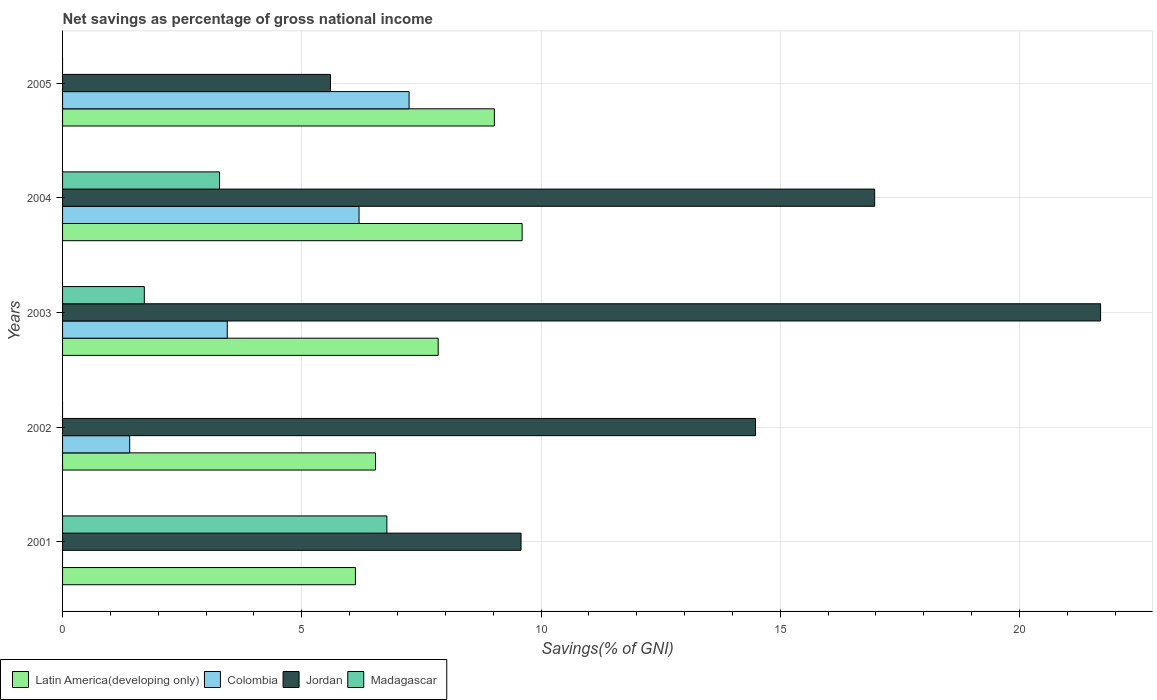How many different coloured bars are there?
Ensure brevity in your answer.  4. How many groups of bars are there?
Offer a terse response. 5. What is the total savings in Colombia in 2004?
Provide a succinct answer. 6.2. Across all years, what is the maximum total savings in Colombia?
Keep it short and to the point. 7.24. Across all years, what is the minimum total savings in Madagascar?
Make the answer very short. 0. What is the total total savings in Colombia in the graph?
Your response must be concise. 18.28. What is the difference between the total savings in Colombia in 2002 and that in 2005?
Your answer should be compact. -5.84. What is the difference between the total savings in Madagascar in 2005 and the total savings in Colombia in 2002?
Your answer should be compact. -1.4. What is the average total savings in Madagascar per year?
Provide a succinct answer. 2.35. In the year 2001, what is the difference between the total savings in Jordan and total savings in Latin America(developing only)?
Your response must be concise. 3.46. What is the ratio of the total savings in Jordan in 2002 to that in 2003?
Your response must be concise. 0.67. Is the total savings in Colombia in 2003 less than that in 2005?
Offer a terse response. Yes. Is the difference between the total savings in Jordan in 2002 and 2003 greater than the difference between the total savings in Latin America(developing only) in 2002 and 2003?
Provide a short and direct response. No. What is the difference between the highest and the second highest total savings in Madagascar?
Your response must be concise. 3.5. What is the difference between the highest and the lowest total savings in Jordan?
Ensure brevity in your answer.  16.1. Is the sum of the total savings in Jordan in 2004 and 2005 greater than the maximum total savings in Latin America(developing only) across all years?
Ensure brevity in your answer.  Yes. How many bars are there?
Your response must be concise. 17. How many legend labels are there?
Offer a terse response. 4. How are the legend labels stacked?
Your answer should be very brief. Horizontal. What is the title of the graph?
Your response must be concise. Net savings as percentage of gross national income. What is the label or title of the X-axis?
Offer a terse response. Savings(% of GNI). What is the label or title of the Y-axis?
Ensure brevity in your answer.  Years. What is the Savings(% of GNI) of Latin America(developing only) in 2001?
Offer a terse response. 6.12. What is the Savings(% of GNI) of Jordan in 2001?
Provide a succinct answer. 9.58. What is the Savings(% of GNI) in Madagascar in 2001?
Ensure brevity in your answer.  6.78. What is the Savings(% of GNI) in Latin America(developing only) in 2002?
Offer a very short reply. 6.54. What is the Savings(% of GNI) of Colombia in 2002?
Your answer should be compact. 1.4. What is the Savings(% of GNI) in Jordan in 2002?
Your response must be concise. 14.48. What is the Savings(% of GNI) of Latin America(developing only) in 2003?
Make the answer very short. 7.85. What is the Savings(% of GNI) in Colombia in 2003?
Make the answer very short. 3.44. What is the Savings(% of GNI) in Jordan in 2003?
Offer a very short reply. 21.69. What is the Savings(% of GNI) of Madagascar in 2003?
Your answer should be very brief. 1.71. What is the Savings(% of GNI) in Latin America(developing only) in 2004?
Offer a terse response. 9.6. What is the Savings(% of GNI) of Colombia in 2004?
Provide a succinct answer. 6.2. What is the Savings(% of GNI) in Jordan in 2004?
Make the answer very short. 16.97. What is the Savings(% of GNI) in Madagascar in 2004?
Ensure brevity in your answer.  3.28. What is the Savings(% of GNI) in Latin America(developing only) in 2005?
Provide a succinct answer. 9.02. What is the Savings(% of GNI) in Colombia in 2005?
Your answer should be compact. 7.24. What is the Savings(% of GNI) of Jordan in 2005?
Keep it short and to the point. 5.6. What is the Savings(% of GNI) in Madagascar in 2005?
Your response must be concise. 0. Across all years, what is the maximum Savings(% of GNI) of Latin America(developing only)?
Make the answer very short. 9.6. Across all years, what is the maximum Savings(% of GNI) of Colombia?
Provide a succinct answer. 7.24. Across all years, what is the maximum Savings(% of GNI) of Jordan?
Ensure brevity in your answer.  21.69. Across all years, what is the maximum Savings(% of GNI) of Madagascar?
Keep it short and to the point. 6.78. Across all years, what is the minimum Savings(% of GNI) of Latin America(developing only)?
Provide a short and direct response. 6.12. Across all years, what is the minimum Savings(% of GNI) in Jordan?
Your answer should be compact. 5.6. Across all years, what is the minimum Savings(% of GNI) of Madagascar?
Your response must be concise. 0. What is the total Savings(% of GNI) in Latin America(developing only) in the graph?
Offer a terse response. 39.14. What is the total Savings(% of GNI) of Colombia in the graph?
Offer a very short reply. 18.28. What is the total Savings(% of GNI) of Jordan in the graph?
Provide a short and direct response. 68.33. What is the total Savings(% of GNI) in Madagascar in the graph?
Ensure brevity in your answer.  11.77. What is the difference between the Savings(% of GNI) of Latin America(developing only) in 2001 and that in 2002?
Offer a terse response. -0.42. What is the difference between the Savings(% of GNI) in Jordan in 2001 and that in 2002?
Ensure brevity in your answer.  -4.9. What is the difference between the Savings(% of GNI) in Latin America(developing only) in 2001 and that in 2003?
Provide a short and direct response. -1.73. What is the difference between the Savings(% of GNI) in Jordan in 2001 and that in 2003?
Your response must be concise. -12.11. What is the difference between the Savings(% of GNI) of Madagascar in 2001 and that in 2003?
Provide a succinct answer. 5.07. What is the difference between the Savings(% of GNI) in Latin America(developing only) in 2001 and that in 2004?
Your answer should be compact. -3.48. What is the difference between the Savings(% of GNI) of Jordan in 2001 and that in 2004?
Give a very brief answer. -7.39. What is the difference between the Savings(% of GNI) in Madagascar in 2001 and that in 2004?
Keep it short and to the point. 3.5. What is the difference between the Savings(% of GNI) in Latin America(developing only) in 2001 and that in 2005?
Offer a terse response. -2.9. What is the difference between the Savings(% of GNI) in Jordan in 2001 and that in 2005?
Give a very brief answer. 3.98. What is the difference between the Savings(% of GNI) of Latin America(developing only) in 2002 and that in 2003?
Your answer should be compact. -1.31. What is the difference between the Savings(% of GNI) in Colombia in 2002 and that in 2003?
Ensure brevity in your answer.  -2.04. What is the difference between the Savings(% of GNI) of Jordan in 2002 and that in 2003?
Ensure brevity in your answer.  -7.21. What is the difference between the Savings(% of GNI) of Latin America(developing only) in 2002 and that in 2004?
Offer a very short reply. -3.06. What is the difference between the Savings(% of GNI) in Colombia in 2002 and that in 2004?
Ensure brevity in your answer.  -4.79. What is the difference between the Savings(% of GNI) in Jordan in 2002 and that in 2004?
Your response must be concise. -2.49. What is the difference between the Savings(% of GNI) of Latin America(developing only) in 2002 and that in 2005?
Provide a short and direct response. -2.48. What is the difference between the Savings(% of GNI) of Colombia in 2002 and that in 2005?
Your answer should be very brief. -5.84. What is the difference between the Savings(% of GNI) in Jordan in 2002 and that in 2005?
Offer a terse response. 8.88. What is the difference between the Savings(% of GNI) in Latin America(developing only) in 2003 and that in 2004?
Offer a terse response. -1.75. What is the difference between the Savings(% of GNI) of Colombia in 2003 and that in 2004?
Your response must be concise. -2.75. What is the difference between the Savings(% of GNI) in Jordan in 2003 and that in 2004?
Offer a terse response. 4.72. What is the difference between the Savings(% of GNI) in Madagascar in 2003 and that in 2004?
Offer a very short reply. -1.57. What is the difference between the Savings(% of GNI) in Latin America(developing only) in 2003 and that in 2005?
Make the answer very short. -1.17. What is the difference between the Savings(% of GNI) of Colombia in 2003 and that in 2005?
Offer a very short reply. -3.8. What is the difference between the Savings(% of GNI) in Jordan in 2003 and that in 2005?
Your answer should be compact. 16.1. What is the difference between the Savings(% of GNI) of Latin America(developing only) in 2004 and that in 2005?
Your answer should be very brief. 0.58. What is the difference between the Savings(% of GNI) of Colombia in 2004 and that in 2005?
Make the answer very short. -1.05. What is the difference between the Savings(% of GNI) of Jordan in 2004 and that in 2005?
Provide a succinct answer. 11.37. What is the difference between the Savings(% of GNI) of Latin America(developing only) in 2001 and the Savings(% of GNI) of Colombia in 2002?
Give a very brief answer. 4.72. What is the difference between the Savings(% of GNI) in Latin America(developing only) in 2001 and the Savings(% of GNI) in Jordan in 2002?
Keep it short and to the point. -8.36. What is the difference between the Savings(% of GNI) of Latin America(developing only) in 2001 and the Savings(% of GNI) of Colombia in 2003?
Keep it short and to the point. 2.68. What is the difference between the Savings(% of GNI) of Latin America(developing only) in 2001 and the Savings(% of GNI) of Jordan in 2003?
Your answer should be very brief. -15.57. What is the difference between the Savings(% of GNI) of Latin America(developing only) in 2001 and the Savings(% of GNI) of Madagascar in 2003?
Your answer should be very brief. 4.41. What is the difference between the Savings(% of GNI) in Jordan in 2001 and the Savings(% of GNI) in Madagascar in 2003?
Offer a terse response. 7.87. What is the difference between the Savings(% of GNI) in Latin America(developing only) in 2001 and the Savings(% of GNI) in Colombia in 2004?
Offer a very short reply. -0.08. What is the difference between the Savings(% of GNI) in Latin America(developing only) in 2001 and the Savings(% of GNI) in Jordan in 2004?
Provide a short and direct response. -10.85. What is the difference between the Savings(% of GNI) in Latin America(developing only) in 2001 and the Savings(% of GNI) in Madagascar in 2004?
Provide a short and direct response. 2.84. What is the difference between the Savings(% of GNI) of Jordan in 2001 and the Savings(% of GNI) of Madagascar in 2004?
Your answer should be very brief. 6.3. What is the difference between the Savings(% of GNI) of Latin America(developing only) in 2001 and the Savings(% of GNI) of Colombia in 2005?
Keep it short and to the point. -1.12. What is the difference between the Savings(% of GNI) of Latin America(developing only) in 2001 and the Savings(% of GNI) of Jordan in 2005?
Offer a very short reply. 0.52. What is the difference between the Savings(% of GNI) of Latin America(developing only) in 2002 and the Savings(% of GNI) of Colombia in 2003?
Offer a very short reply. 3.1. What is the difference between the Savings(% of GNI) of Latin America(developing only) in 2002 and the Savings(% of GNI) of Jordan in 2003?
Your response must be concise. -15.15. What is the difference between the Savings(% of GNI) in Latin America(developing only) in 2002 and the Savings(% of GNI) in Madagascar in 2003?
Provide a succinct answer. 4.83. What is the difference between the Savings(% of GNI) in Colombia in 2002 and the Savings(% of GNI) in Jordan in 2003?
Provide a succinct answer. -20.29. What is the difference between the Savings(% of GNI) in Colombia in 2002 and the Savings(% of GNI) in Madagascar in 2003?
Keep it short and to the point. -0.31. What is the difference between the Savings(% of GNI) in Jordan in 2002 and the Savings(% of GNI) in Madagascar in 2003?
Make the answer very short. 12.77. What is the difference between the Savings(% of GNI) in Latin America(developing only) in 2002 and the Savings(% of GNI) in Colombia in 2004?
Offer a very short reply. 0.34. What is the difference between the Savings(% of GNI) of Latin America(developing only) in 2002 and the Savings(% of GNI) of Jordan in 2004?
Provide a short and direct response. -10.43. What is the difference between the Savings(% of GNI) of Latin America(developing only) in 2002 and the Savings(% of GNI) of Madagascar in 2004?
Give a very brief answer. 3.26. What is the difference between the Savings(% of GNI) in Colombia in 2002 and the Savings(% of GNI) in Jordan in 2004?
Your answer should be very brief. -15.57. What is the difference between the Savings(% of GNI) of Colombia in 2002 and the Savings(% of GNI) of Madagascar in 2004?
Keep it short and to the point. -1.88. What is the difference between the Savings(% of GNI) of Jordan in 2002 and the Savings(% of GNI) of Madagascar in 2004?
Your answer should be compact. 11.2. What is the difference between the Savings(% of GNI) in Latin America(developing only) in 2002 and the Savings(% of GNI) in Colombia in 2005?
Offer a very short reply. -0.7. What is the difference between the Savings(% of GNI) of Latin America(developing only) in 2002 and the Savings(% of GNI) of Jordan in 2005?
Provide a succinct answer. 0.94. What is the difference between the Savings(% of GNI) in Colombia in 2002 and the Savings(% of GNI) in Jordan in 2005?
Make the answer very short. -4.2. What is the difference between the Savings(% of GNI) in Latin America(developing only) in 2003 and the Savings(% of GNI) in Colombia in 2004?
Ensure brevity in your answer.  1.65. What is the difference between the Savings(% of GNI) in Latin America(developing only) in 2003 and the Savings(% of GNI) in Jordan in 2004?
Keep it short and to the point. -9.12. What is the difference between the Savings(% of GNI) of Latin America(developing only) in 2003 and the Savings(% of GNI) of Madagascar in 2004?
Offer a terse response. 4.57. What is the difference between the Savings(% of GNI) in Colombia in 2003 and the Savings(% of GNI) in Jordan in 2004?
Make the answer very short. -13.53. What is the difference between the Savings(% of GNI) of Colombia in 2003 and the Savings(% of GNI) of Madagascar in 2004?
Provide a short and direct response. 0.16. What is the difference between the Savings(% of GNI) in Jordan in 2003 and the Savings(% of GNI) in Madagascar in 2004?
Ensure brevity in your answer.  18.41. What is the difference between the Savings(% of GNI) of Latin America(developing only) in 2003 and the Savings(% of GNI) of Colombia in 2005?
Provide a short and direct response. 0.61. What is the difference between the Savings(% of GNI) in Latin America(developing only) in 2003 and the Savings(% of GNI) in Jordan in 2005?
Your response must be concise. 2.25. What is the difference between the Savings(% of GNI) in Colombia in 2003 and the Savings(% of GNI) in Jordan in 2005?
Ensure brevity in your answer.  -2.16. What is the difference between the Savings(% of GNI) of Latin America(developing only) in 2004 and the Savings(% of GNI) of Colombia in 2005?
Your answer should be very brief. 2.36. What is the difference between the Savings(% of GNI) in Latin America(developing only) in 2004 and the Savings(% of GNI) in Jordan in 2005?
Offer a terse response. 4.01. What is the difference between the Savings(% of GNI) in Colombia in 2004 and the Savings(% of GNI) in Jordan in 2005?
Make the answer very short. 0.6. What is the average Savings(% of GNI) in Latin America(developing only) per year?
Keep it short and to the point. 7.83. What is the average Savings(% of GNI) of Colombia per year?
Your response must be concise. 3.66. What is the average Savings(% of GNI) in Jordan per year?
Give a very brief answer. 13.67. What is the average Savings(% of GNI) of Madagascar per year?
Ensure brevity in your answer.  2.35. In the year 2001, what is the difference between the Savings(% of GNI) in Latin America(developing only) and Savings(% of GNI) in Jordan?
Offer a terse response. -3.46. In the year 2001, what is the difference between the Savings(% of GNI) of Latin America(developing only) and Savings(% of GNI) of Madagascar?
Your answer should be very brief. -0.66. In the year 2001, what is the difference between the Savings(% of GNI) in Jordan and Savings(% of GNI) in Madagascar?
Ensure brevity in your answer.  2.8. In the year 2002, what is the difference between the Savings(% of GNI) in Latin America(developing only) and Savings(% of GNI) in Colombia?
Your answer should be compact. 5.14. In the year 2002, what is the difference between the Savings(% of GNI) of Latin America(developing only) and Savings(% of GNI) of Jordan?
Ensure brevity in your answer.  -7.94. In the year 2002, what is the difference between the Savings(% of GNI) of Colombia and Savings(% of GNI) of Jordan?
Your response must be concise. -13.08. In the year 2003, what is the difference between the Savings(% of GNI) in Latin America(developing only) and Savings(% of GNI) in Colombia?
Keep it short and to the point. 4.41. In the year 2003, what is the difference between the Savings(% of GNI) of Latin America(developing only) and Savings(% of GNI) of Jordan?
Ensure brevity in your answer.  -13.84. In the year 2003, what is the difference between the Savings(% of GNI) in Latin America(developing only) and Savings(% of GNI) in Madagascar?
Your answer should be very brief. 6.14. In the year 2003, what is the difference between the Savings(% of GNI) in Colombia and Savings(% of GNI) in Jordan?
Keep it short and to the point. -18.25. In the year 2003, what is the difference between the Savings(% of GNI) in Colombia and Savings(% of GNI) in Madagascar?
Offer a very short reply. 1.73. In the year 2003, what is the difference between the Savings(% of GNI) in Jordan and Savings(% of GNI) in Madagascar?
Provide a short and direct response. 19.99. In the year 2004, what is the difference between the Savings(% of GNI) of Latin America(developing only) and Savings(% of GNI) of Colombia?
Make the answer very short. 3.41. In the year 2004, what is the difference between the Savings(% of GNI) in Latin America(developing only) and Savings(% of GNI) in Jordan?
Offer a terse response. -7.37. In the year 2004, what is the difference between the Savings(% of GNI) of Latin America(developing only) and Savings(% of GNI) of Madagascar?
Your response must be concise. 6.33. In the year 2004, what is the difference between the Savings(% of GNI) in Colombia and Savings(% of GNI) in Jordan?
Keep it short and to the point. -10.78. In the year 2004, what is the difference between the Savings(% of GNI) in Colombia and Savings(% of GNI) in Madagascar?
Ensure brevity in your answer.  2.92. In the year 2004, what is the difference between the Savings(% of GNI) in Jordan and Savings(% of GNI) in Madagascar?
Keep it short and to the point. 13.69. In the year 2005, what is the difference between the Savings(% of GNI) in Latin America(developing only) and Savings(% of GNI) in Colombia?
Offer a very short reply. 1.78. In the year 2005, what is the difference between the Savings(% of GNI) in Latin America(developing only) and Savings(% of GNI) in Jordan?
Your answer should be very brief. 3.43. In the year 2005, what is the difference between the Savings(% of GNI) in Colombia and Savings(% of GNI) in Jordan?
Make the answer very short. 1.64. What is the ratio of the Savings(% of GNI) of Latin America(developing only) in 2001 to that in 2002?
Ensure brevity in your answer.  0.94. What is the ratio of the Savings(% of GNI) of Jordan in 2001 to that in 2002?
Offer a terse response. 0.66. What is the ratio of the Savings(% of GNI) in Latin America(developing only) in 2001 to that in 2003?
Make the answer very short. 0.78. What is the ratio of the Savings(% of GNI) in Jordan in 2001 to that in 2003?
Offer a terse response. 0.44. What is the ratio of the Savings(% of GNI) of Madagascar in 2001 to that in 2003?
Keep it short and to the point. 3.97. What is the ratio of the Savings(% of GNI) of Latin America(developing only) in 2001 to that in 2004?
Your answer should be compact. 0.64. What is the ratio of the Savings(% of GNI) in Jordan in 2001 to that in 2004?
Make the answer very short. 0.56. What is the ratio of the Savings(% of GNI) in Madagascar in 2001 to that in 2004?
Make the answer very short. 2.07. What is the ratio of the Savings(% of GNI) in Latin America(developing only) in 2001 to that in 2005?
Your answer should be compact. 0.68. What is the ratio of the Savings(% of GNI) in Jordan in 2001 to that in 2005?
Make the answer very short. 1.71. What is the ratio of the Savings(% of GNI) of Latin America(developing only) in 2002 to that in 2003?
Give a very brief answer. 0.83. What is the ratio of the Savings(% of GNI) in Colombia in 2002 to that in 2003?
Provide a succinct answer. 0.41. What is the ratio of the Savings(% of GNI) of Jordan in 2002 to that in 2003?
Offer a terse response. 0.67. What is the ratio of the Savings(% of GNI) of Latin America(developing only) in 2002 to that in 2004?
Make the answer very short. 0.68. What is the ratio of the Savings(% of GNI) in Colombia in 2002 to that in 2004?
Your answer should be very brief. 0.23. What is the ratio of the Savings(% of GNI) in Jordan in 2002 to that in 2004?
Give a very brief answer. 0.85. What is the ratio of the Savings(% of GNI) in Latin America(developing only) in 2002 to that in 2005?
Your answer should be compact. 0.72. What is the ratio of the Savings(% of GNI) of Colombia in 2002 to that in 2005?
Your response must be concise. 0.19. What is the ratio of the Savings(% of GNI) of Jordan in 2002 to that in 2005?
Provide a succinct answer. 2.59. What is the ratio of the Savings(% of GNI) of Latin America(developing only) in 2003 to that in 2004?
Offer a very short reply. 0.82. What is the ratio of the Savings(% of GNI) of Colombia in 2003 to that in 2004?
Give a very brief answer. 0.56. What is the ratio of the Savings(% of GNI) of Jordan in 2003 to that in 2004?
Your response must be concise. 1.28. What is the ratio of the Savings(% of GNI) in Madagascar in 2003 to that in 2004?
Your answer should be compact. 0.52. What is the ratio of the Savings(% of GNI) of Latin America(developing only) in 2003 to that in 2005?
Provide a short and direct response. 0.87. What is the ratio of the Savings(% of GNI) in Colombia in 2003 to that in 2005?
Your answer should be very brief. 0.48. What is the ratio of the Savings(% of GNI) of Jordan in 2003 to that in 2005?
Your answer should be compact. 3.87. What is the ratio of the Savings(% of GNI) of Latin America(developing only) in 2004 to that in 2005?
Ensure brevity in your answer.  1.06. What is the ratio of the Savings(% of GNI) in Colombia in 2004 to that in 2005?
Give a very brief answer. 0.86. What is the ratio of the Savings(% of GNI) of Jordan in 2004 to that in 2005?
Your answer should be very brief. 3.03. What is the difference between the highest and the second highest Savings(% of GNI) in Latin America(developing only)?
Offer a very short reply. 0.58. What is the difference between the highest and the second highest Savings(% of GNI) in Colombia?
Your response must be concise. 1.05. What is the difference between the highest and the second highest Savings(% of GNI) in Jordan?
Your answer should be compact. 4.72. What is the difference between the highest and the second highest Savings(% of GNI) of Madagascar?
Your answer should be compact. 3.5. What is the difference between the highest and the lowest Savings(% of GNI) in Latin America(developing only)?
Your response must be concise. 3.48. What is the difference between the highest and the lowest Savings(% of GNI) of Colombia?
Make the answer very short. 7.24. What is the difference between the highest and the lowest Savings(% of GNI) in Jordan?
Offer a very short reply. 16.1. What is the difference between the highest and the lowest Savings(% of GNI) in Madagascar?
Offer a terse response. 6.78. 